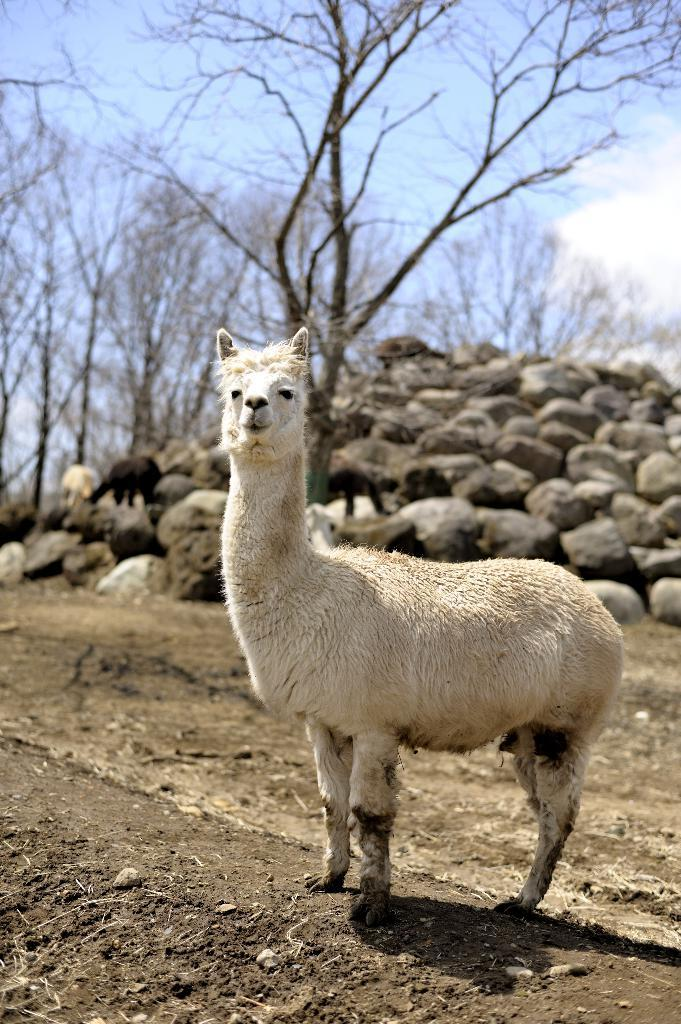What type of animal can be seen in the image? There is an animal in the image, but its specific type cannot be determined from the provided facts. What color is the animal in the image? The animal is white in color. What type of natural features are visible in the image? Rocks and dry trees are present in the image. What is the color of the sky in the image? The sky is blue and white in color. How many children are playing with the cable in the image? There is no cable or children present in the image. What is the value of the cent in the image? There is no cent or any monetary value mentioned in the image. 